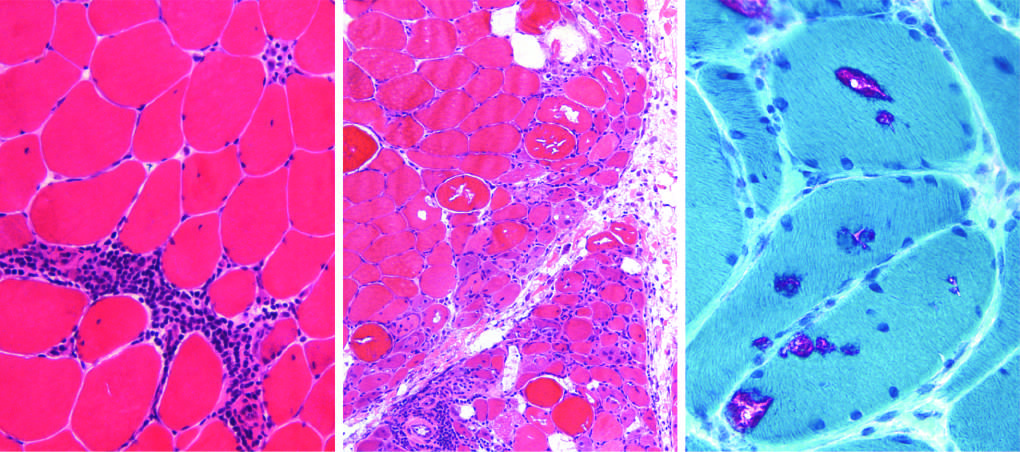does schematic diagram of intimal thickening show prominent perifascicular and paraseptal atrophy?
Answer the question using a single word or phrase. No 